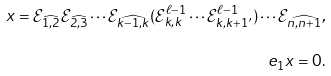Convert formula to latex. <formula><loc_0><loc_0><loc_500><loc_500>x = \mathcal { E } _ { \widehat { 1 , 2 } } \mathcal { E } _ { \widehat { 2 , 3 } } \cdots \mathcal { E } _ { \widehat { k - 1 , k } } ( \mathcal { E } _ { k , k } ^ { \ell - 1 } \cdots \mathcal { E } _ { k , k + 1 ^ { \prime } } ^ { \ell - 1 } ) \cdots \mathcal { E } _ { \widehat { n , n + 1 } } , \\ e _ { 1 } x = 0 .</formula> 